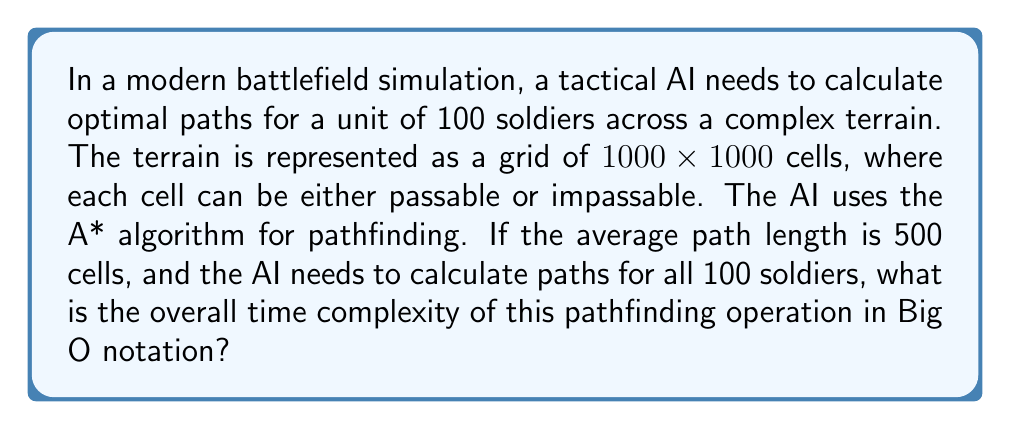Give your solution to this math problem. To solve this problem, we need to consider the following steps:

1. Understand the A* algorithm's time complexity:
   The time complexity of A* is $O(b^d)$, where $b$ is the branching factor (average number of successors per state) and $d$ is the depth of the solution.

2. Analyze the given information:
   - Grid size: $1000 \times 1000 = 10^6$ cells
   - Number of soldiers: 100
   - Average path length: 500 cells

3. Estimate the branching factor:
   In a grid-based terrain, the branching factor is typically between 4 (cardinal directions) and 8 (including diagonals). Let's assume $b = 8$ for this problem.

4. Calculate the time complexity for a single pathfinding operation:
   $O(b^d) = O(8^{500})$

5. Consider the number of soldiers:
   Since we need to calculate paths for 100 soldiers, we multiply the time complexity by 100:
   $100 \times O(8^{500})$

6. Simplify the notation:
   The constant factor (100) can be dropped in Big O notation, so the final time complexity remains $O(8^{500})$.

It's important to note that while this is the theoretical worst-case time complexity, in practice, heuristics and optimizations in the A* algorithm often lead to much better average-case performance.
Answer: $O(8^{500})$ 